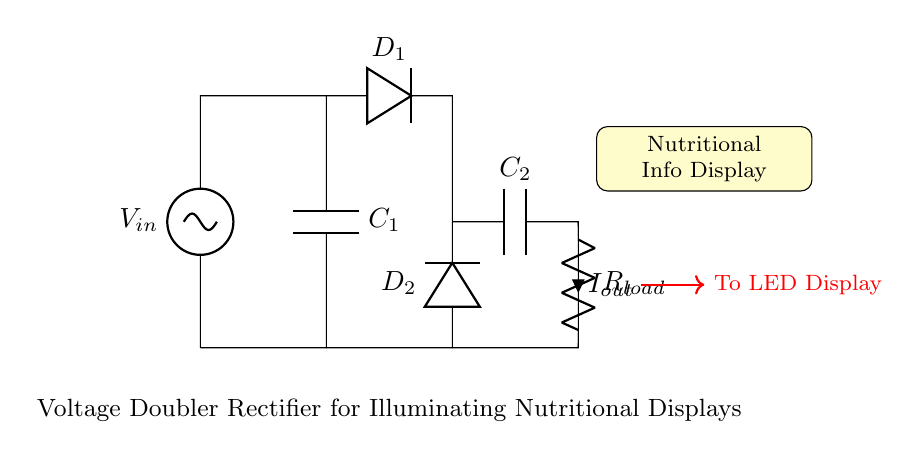What does the circuit aim to illuminate? The circuit is designed to illuminate a nutritional information display, as indicated by the label in the diagram.
Answer: Nutritional Info Display What are the components used in this circuit? The circuit consists of two capacitors, two diodes, a voltage source, and a resistor. These elements are clearly labeled in the diagram.
Answer: Capacitors, diodes, voltage source, resistor What is the configuration of the diodes in the circuit? The diodes are configured in a way that they conduct current during different half cycles of the input voltage, which is characteristic of a voltage doubler arrangement.
Answer: Voltage doubler What is the purpose of the capacitors in this circuit? The capacitors serve to store electrical energy, which allows for doubling the output voltage and smoothing the output current for the load.
Answer: Store electrical energy How many outputs does this circuit have? The circuit has one output, which connects to the LED display symbolizing the load in the diagram.
Answer: One output What is the function of the load resistor? The load resistor dissipates energy to illuminate the display, allowing for a visual representation of the nutritional information powered by the voltage doubler.
Answer: Illuminate display What type of rectifier is represented in this circuit? The circuit represents a voltage doubler rectifier, which is specifically designed to increase the voltage from the input to the output for the connected load.
Answer: Voltage doubler rectifier 